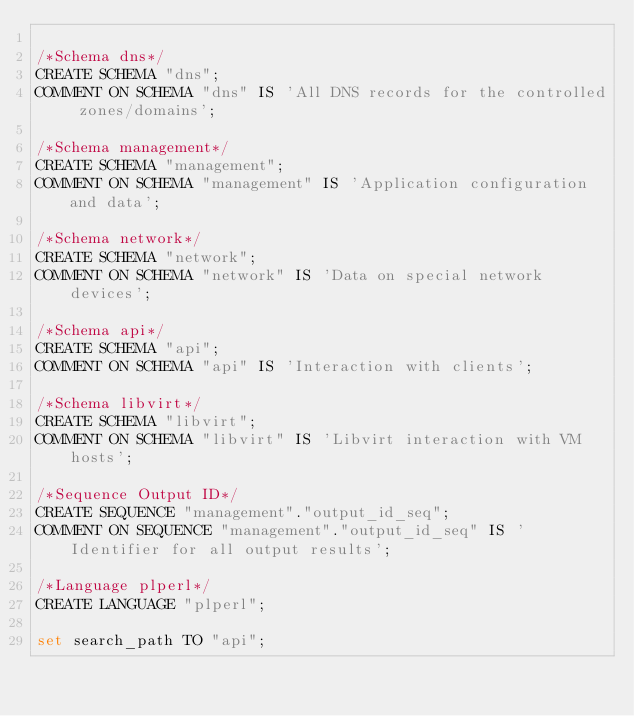Convert code to text. <code><loc_0><loc_0><loc_500><loc_500><_SQL_>
/*Schema dns*/
CREATE SCHEMA "dns";
COMMENT ON SCHEMA "dns" IS 'All DNS records for the controlled zones/domains';

/*Schema management*/
CREATE SCHEMA "management";
COMMENT ON SCHEMA "management" IS 'Application configuration and data';

/*Schema network*/
CREATE SCHEMA "network";
COMMENT ON SCHEMA "network" IS 'Data on special network devices';

/*Schema api*/
CREATE SCHEMA "api";
COMMENT ON SCHEMA "api" IS 'Interaction with clients';

/*Schema libvirt*/
CREATE SCHEMA "libvirt";
COMMENT ON SCHEMA "libvirt" IS 'Libvirt interaction with VM hosts';

/*Sequence Output ID*/
CREATE SEQUENCE "management"."output_id_seq";
COMMENT ON SEQUENCE "management"."output_id_seq" IS 'Identifier for all output results';

/*Language plperl*/
CREATE LANGUAGE "plperl";

set search_path TO "api";
</code> 